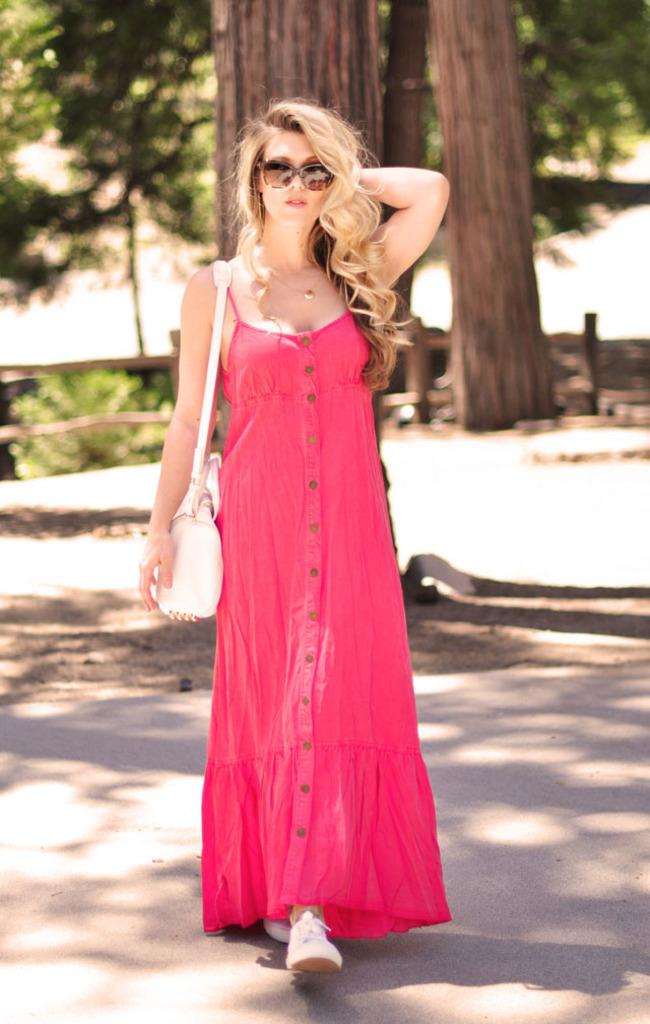Who is the main subject in the image? There is a woman in the image. What is the woman doing in the image? The woman is walking. What can be seen in the background of the image? There are trees visible in the background of the image. What type of insect is the woman holding in the image? There is no insect present in the image; the woman is simply walking. 